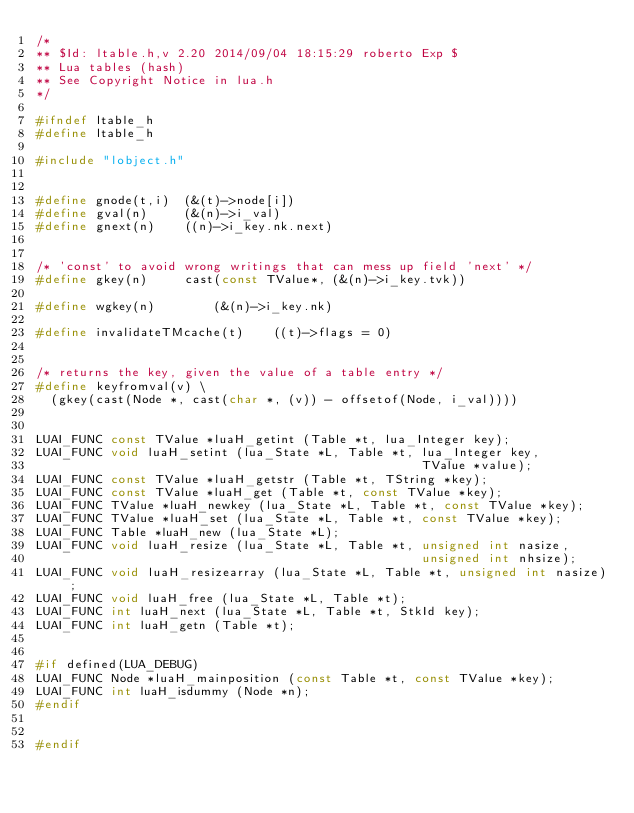Convert code to text. <code><loc_0><loc_0><loc_500><loc_500><_C_>/*
** $Id: ltable.h,v 2.20 2014/09/04 18:15:29 roberto Exp $
** Lua tables (hash)
** See Copyright Notice in lua.h
*/

#ifndef ltable_h
#define ltable_h

#include "lobject.h"


#define gnode(t,i)	(&(t)->node[i])
#define gval(n)		(&(n)->i_val)
#define gnext(n)	((n)->i_key.nk.next)


/* 'const' to avoid wrong writings that can mess up field 'next' */ 
#define gkey(n)		cast(const TValue*, (&(n)->i_key.tvk))

#define wgkey(n)		(&(n)->i_key.nk)

#define invalidateTMcache(t)	((t)->flags = 0)


/* returns the key, given the value of a table entry */
#define keyfromval(v) \
  (gkey(cast(Node *, cast(char *, (v)) - offsetof(Node, i_val))))


LUAI_FUNC const TValue *luaH_getint (Table *t, lua_Integer key);
LUAI_FUNC void luaH_setint (lua_State *L, Table *t, lua_Integer key,
                                                    TValue *value);
LUAI_FUNC const TValue *luaH_getstr (Table *t, TString *key);
LUAI_FUNC const TValue *luaH_get (Table *t, const TValue *key);
LUAI_FUNC TValue *luaH_newkey (lua_State *L, Table *t, const TValue *key);
LUAI_FUNC TValue *luaH_set (lua_State *L, Table *t, const TValue *key);
LUAI_FUNC Table *luaH_new (lua_State *L);
LUAI_FUNC void luaH_resize (lua_State *L, Table *t, unsigned int nasize,
                                                    unsigned int nhsize);
LUAI_FUNC void luaH_resizearray (lua_State *L, Table *t, unsigned int nasize);
LUAI_FUNC void luaH_free (lua_State *L, Table *t);
LUAI_FUNC int luaH_next (lua_State *L, Table *t, StkId key);
LUAI_FUNC int luaH_getn (Table *t);


#if defined(LUA_DEBUG)
LUAI_FUNC Node *luaH_mainposition (const Table *t, const TValue *key);
LUAI_FUNC int luaH_isdummy (Node *n);
#endif


#endif
</code> 